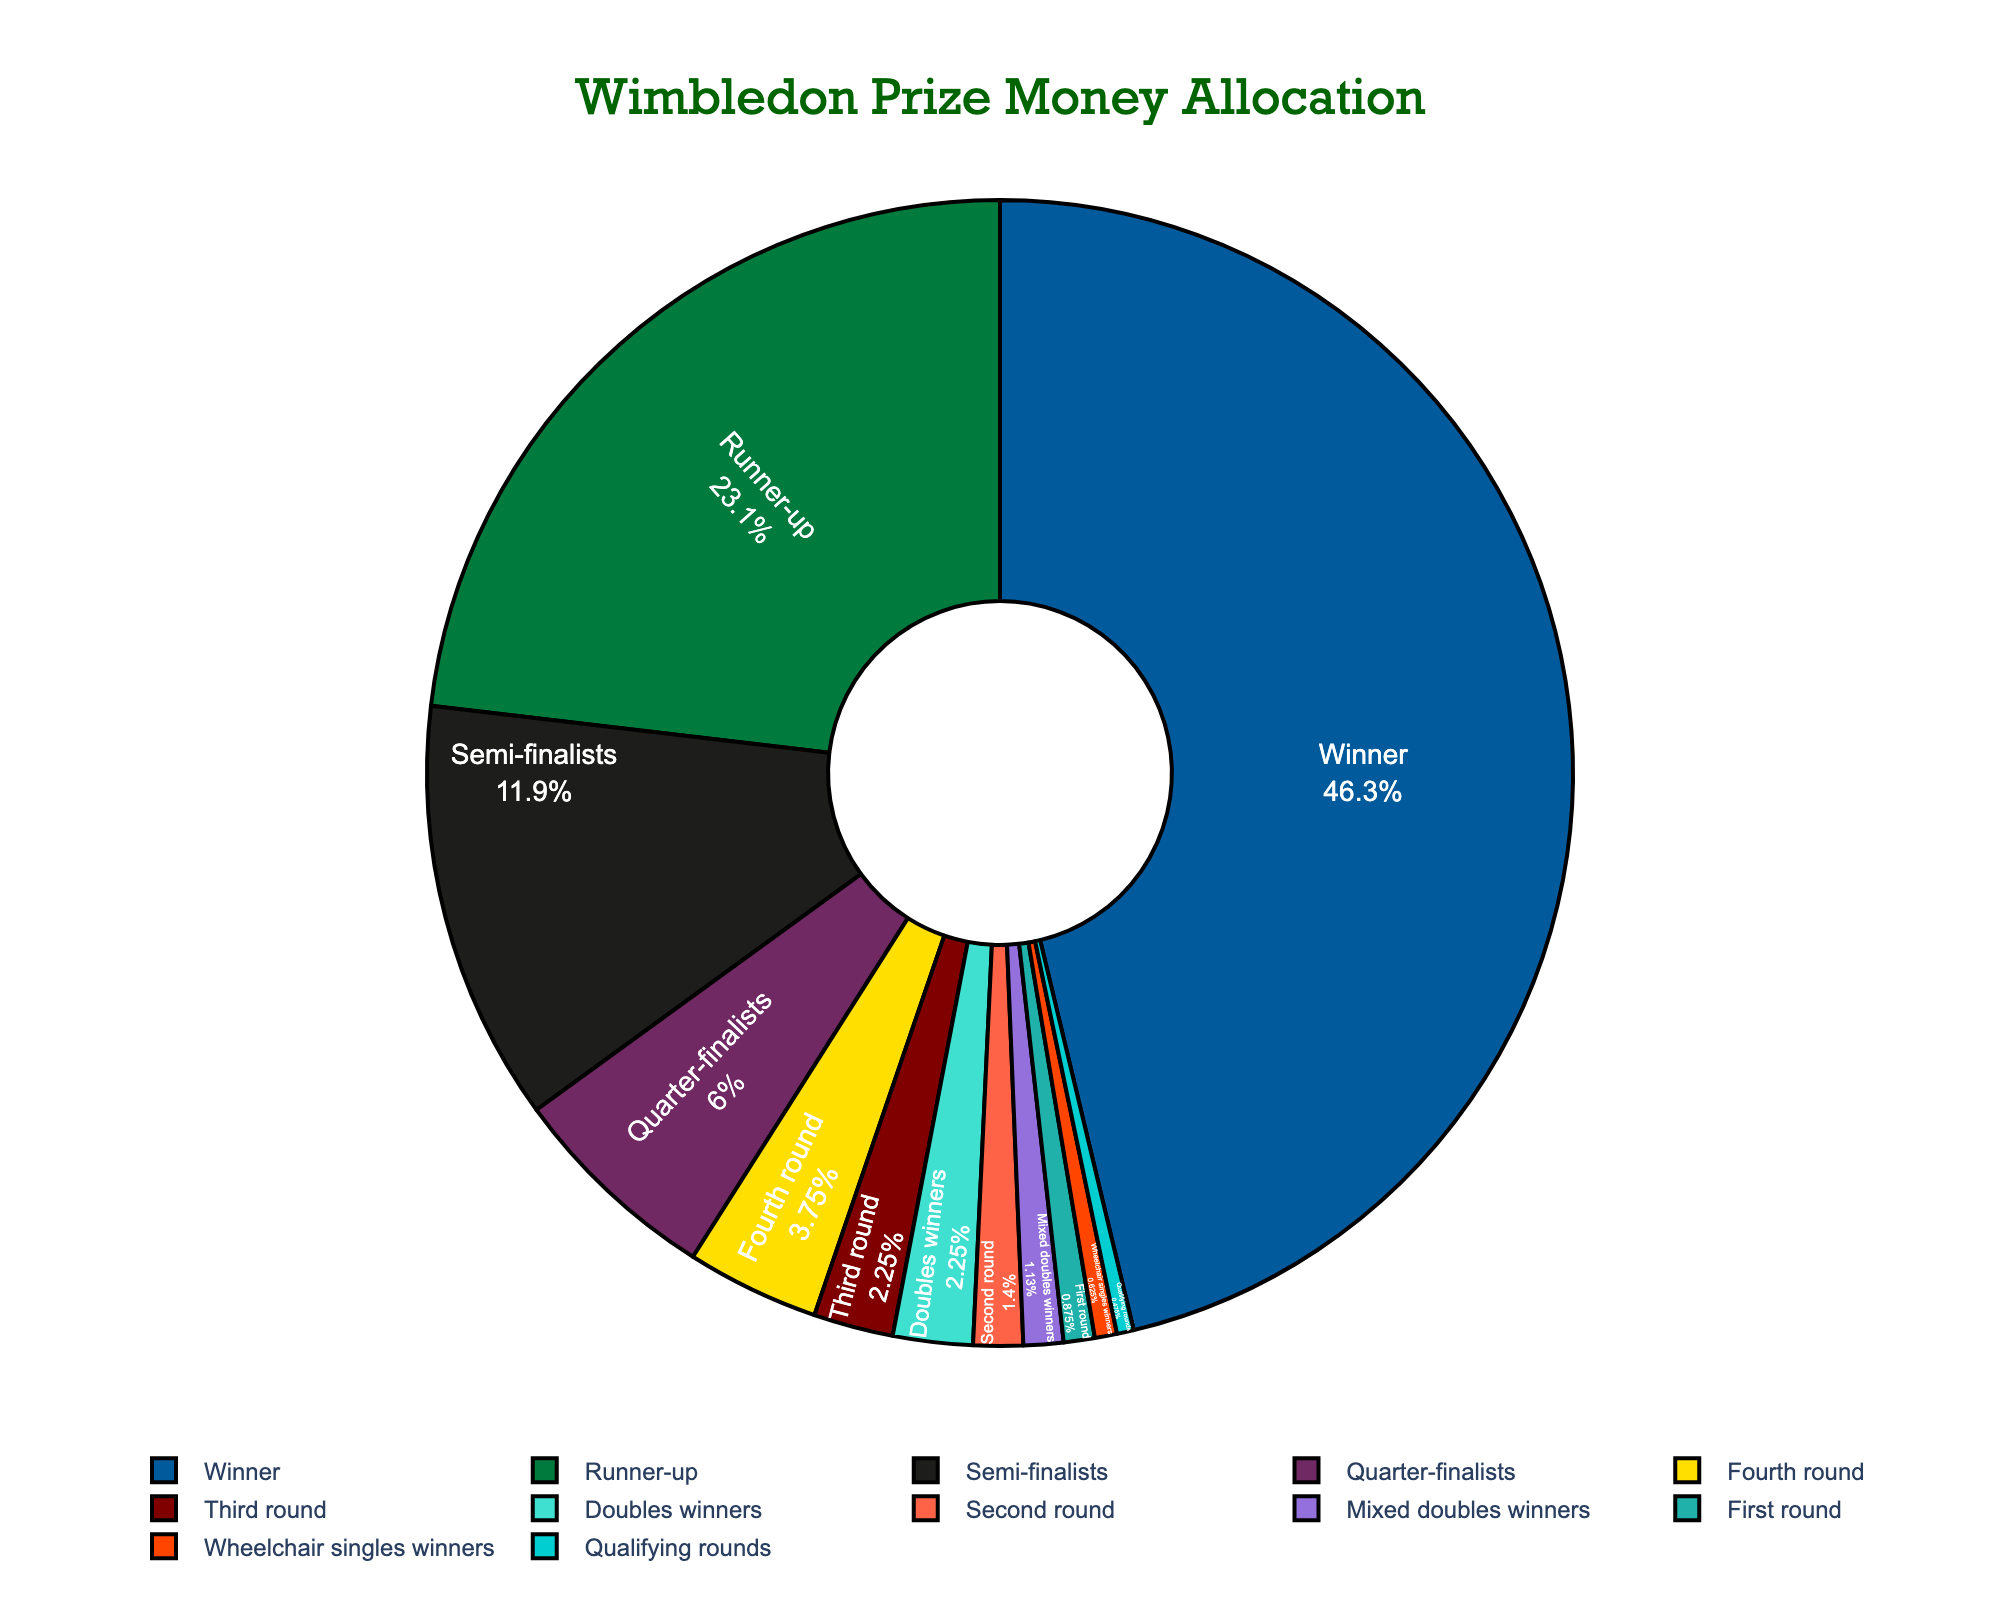What percentage of the prize money is allocated to the winner? The prize money allocated to the winner is directly listed under the "Winner" category on the pie chart.
Answer: 18.5% Which round receives a higher percentage of the prize money allocation: the semi-finalists or the quarter-finalists? Compare the percentages for Semi-finalists (4.75%) and Quarter-finalists (2.4%) directly from the chart.
Answer: Semi-finalists Which specific categories constitute 1% or less of the prize money allocation? Identify all categories where the percentage shown on the chart is 1% or less. These are Third round, Second round, First round, Qualifying rounds, Mixed doubles winners, and Wheelchair singles winners.
Answer: Third round, Second round, First round, Qualifying rounds, Mixed doubles winners, Wheelchair singles winners What is the combined percentage of prize money allocated to the first round and the qualifying rounds? Add the percentages for the First round (0.35%) and Qualifying rounds (0.19%) together: 0.35 + 0.19 = 0.54.
Answer: 0.54% Is the percentage allocation for doubles winners greater than, less than, or equal to that for mixed doubles winners? Compare the percentages for Doubles winners (0.9%) and Mixed doubles winners (0.45%).
Answer: Greater than What is the total percentage of prize money allocated to the top two rounds (Winner and Runner-up)? Sum the percentages for Winner (18.5%) and Runner-up (9.25%): 18.5 + 9.25 = 27.75.
Answer: 27.75% How many different rounds have a percentage allocation that exceeds 2%? Identify all categories with percentage allocations greater than 2%. These are Winner (18.5%), Runner-up (9.25%), and Semi-finalists (4.75%), and Quarter-finalists (2.4%). The total number of such rounds is 4.
Answer: 4 Which category has a percentage allocation closest to 0.5%? Compare the given percentages to 0.5% and find the closest one. The Second round has a percentage allocation of 0.56%, which is closest to 0.5%.
Answer: Second round 